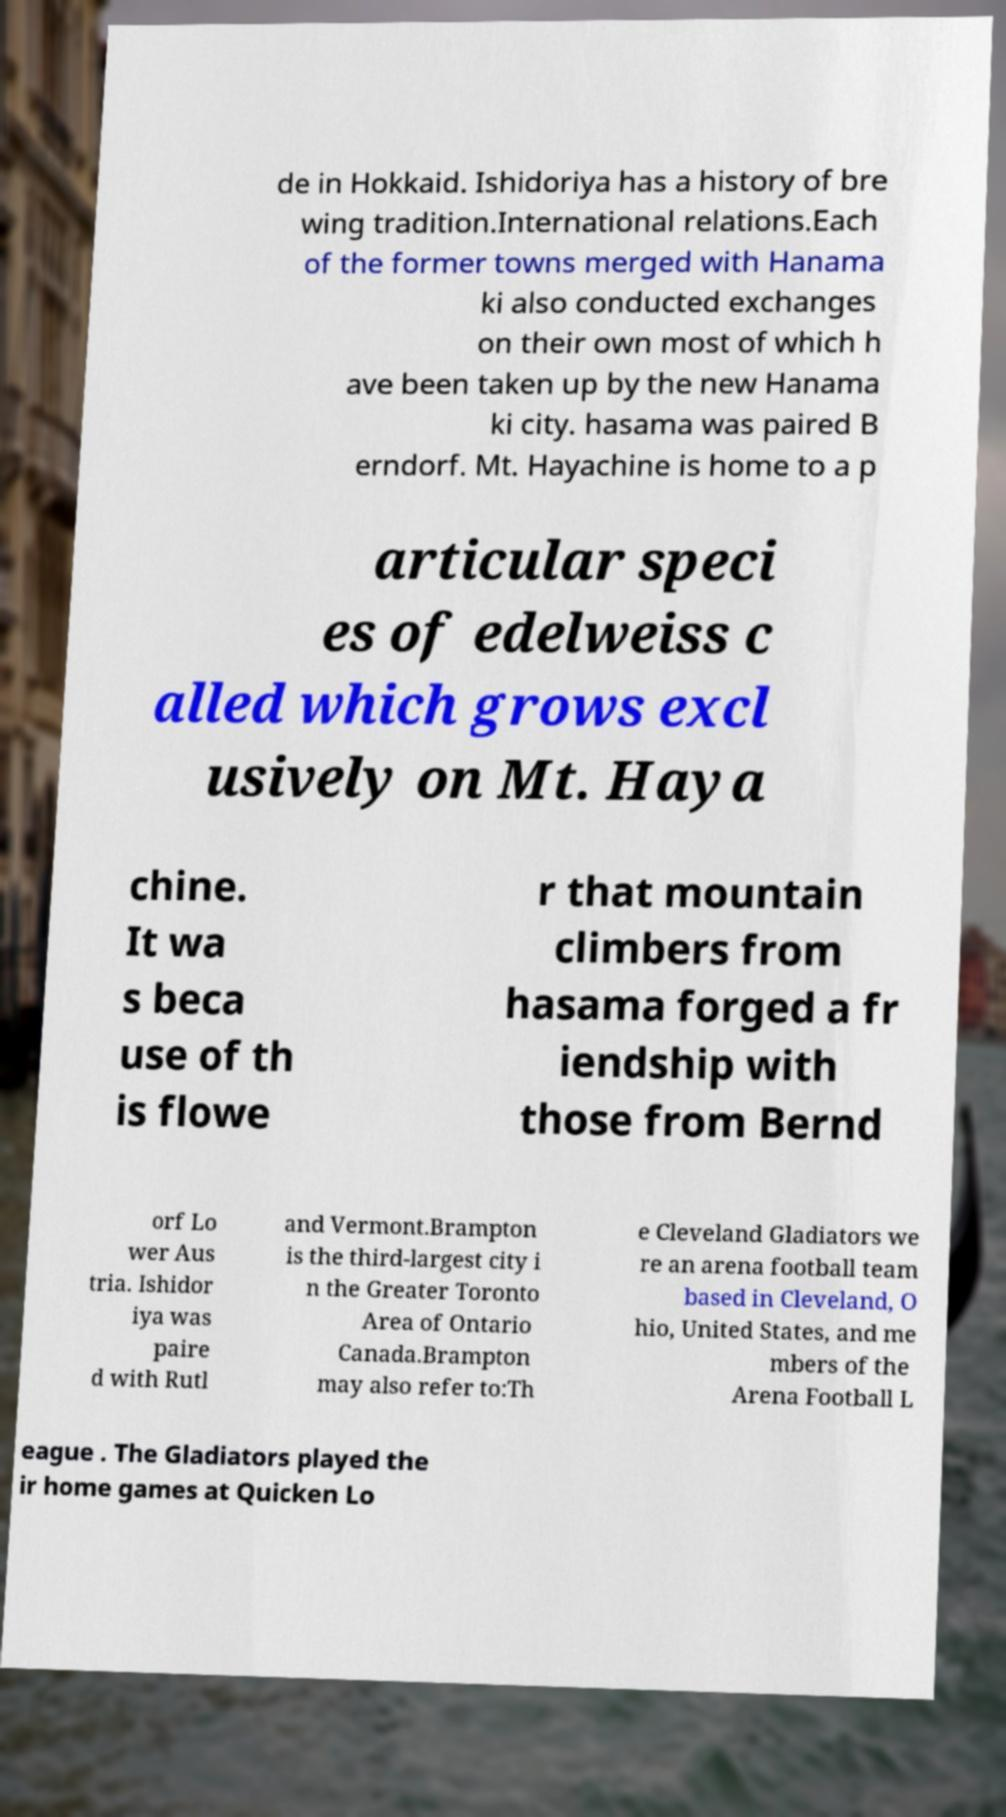Could you extract and type out the text from this image? de in Hokkaid. Ishidoriya has a history of bre wing tradition.International relations.Each of the former towns merged with Hanama ki also conducted exchanges on their own most of which h ave been taken up by the new Hanama ki city. hasama was paired B erndorf. Mt. Hayachine is home to a p articular speci es of edelweiss c alled which grows excl usively on Mt. Haya chine. It wa s beca use of th is flowe r that mountain climbers from hasama forged a fr iendship with those from Bernd orf Lo wer Aus tria. Ishidor iya was paire d with Rutl and Vermont.Brampton is the third-largest city i n the Greater Toronto Area of Ontario Canada.Brampton may also refer to:Th e Cleveland Gladiators we re an arena football team based in Cleveland, O hio, United States, and me mbers of the Arena Football L eague . The Gladiators played the ir home games at Quicken Lo 